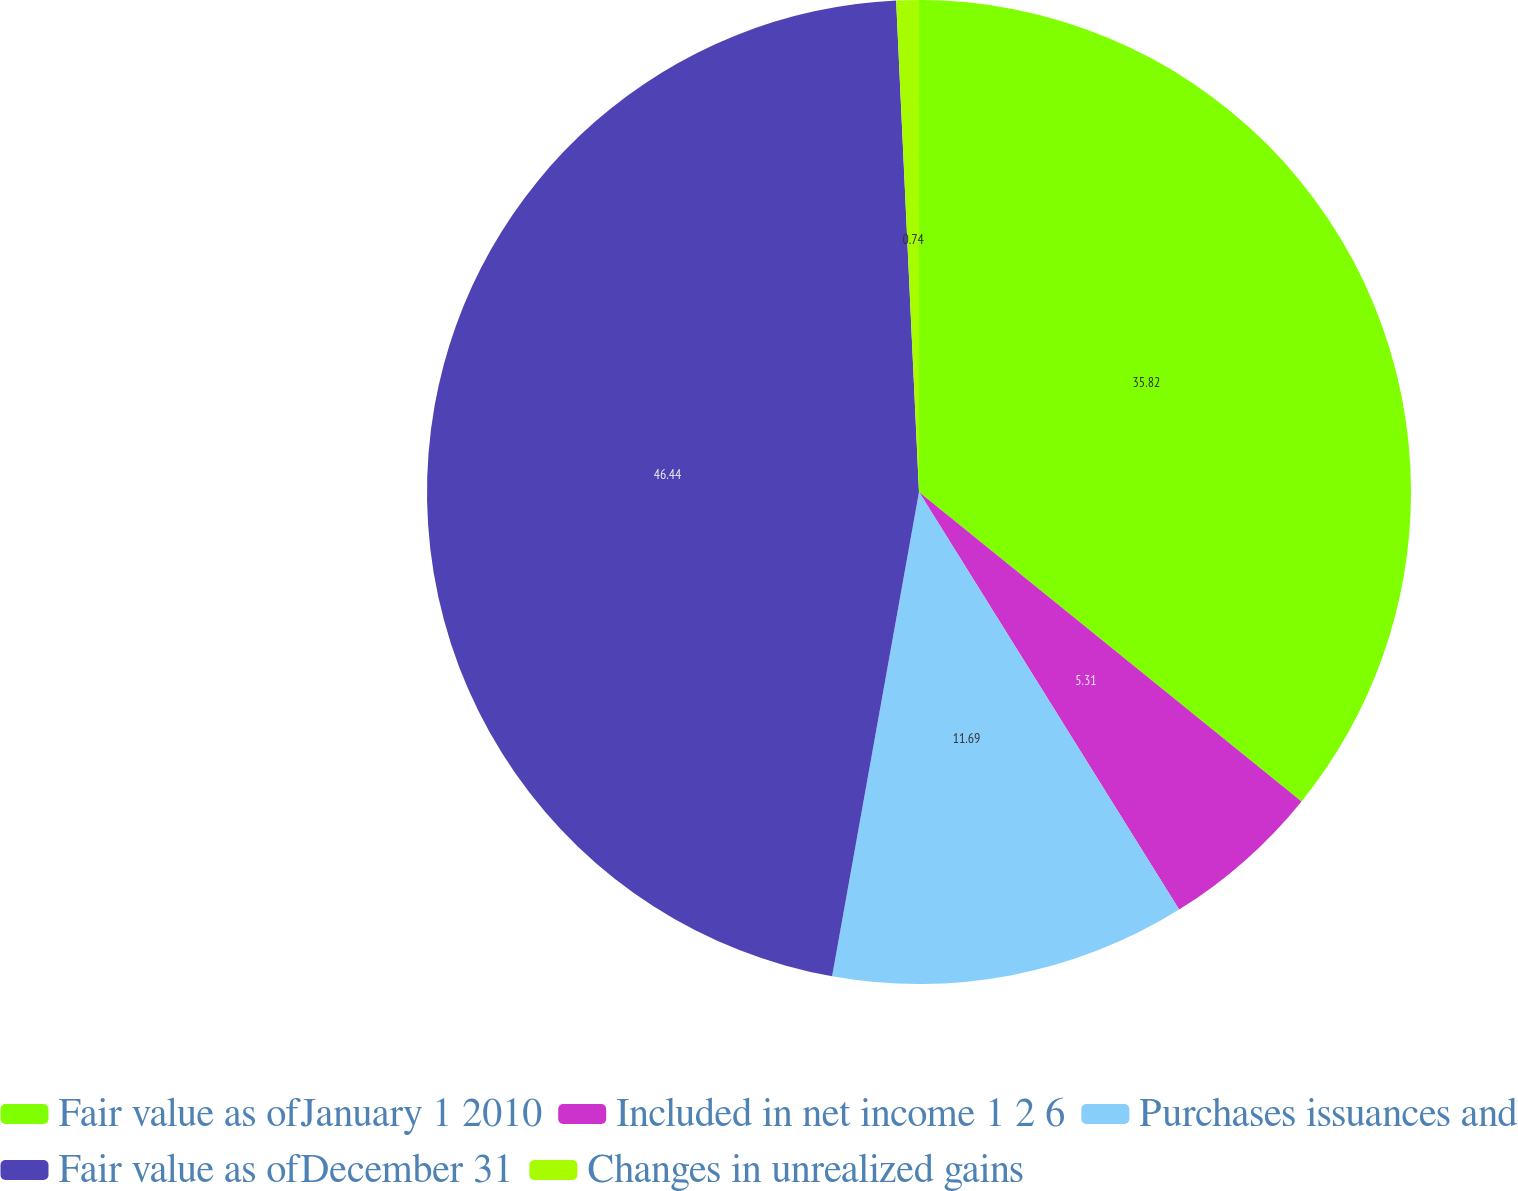Convert chart. <chart><loc_0><loc_0><loc_500><loc_500><pie_chart><fcel>Fair value as ofJanuary 1 2010<fcel>Included in net income 1 2 6<fcel>Purchases issuances and<fcel>Fair value as ofDecember 31<fcel>Changes in unrealized gains<nl><fcel>35.82%<fcel>5.31%<fcel>11.69%<fcel>46.43%<fcel>0.74%<nl></chart> 